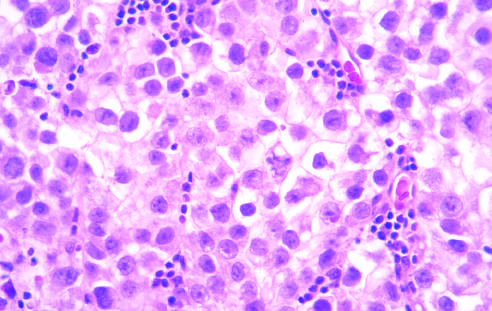does the fibrosis, which varies in intensity, reveal large cells with distinct cell borders, pale nuclei, prominent nucleoli, and a sparse lymphocytic infiltrate?
Answer the question using a single word or phrase. No 